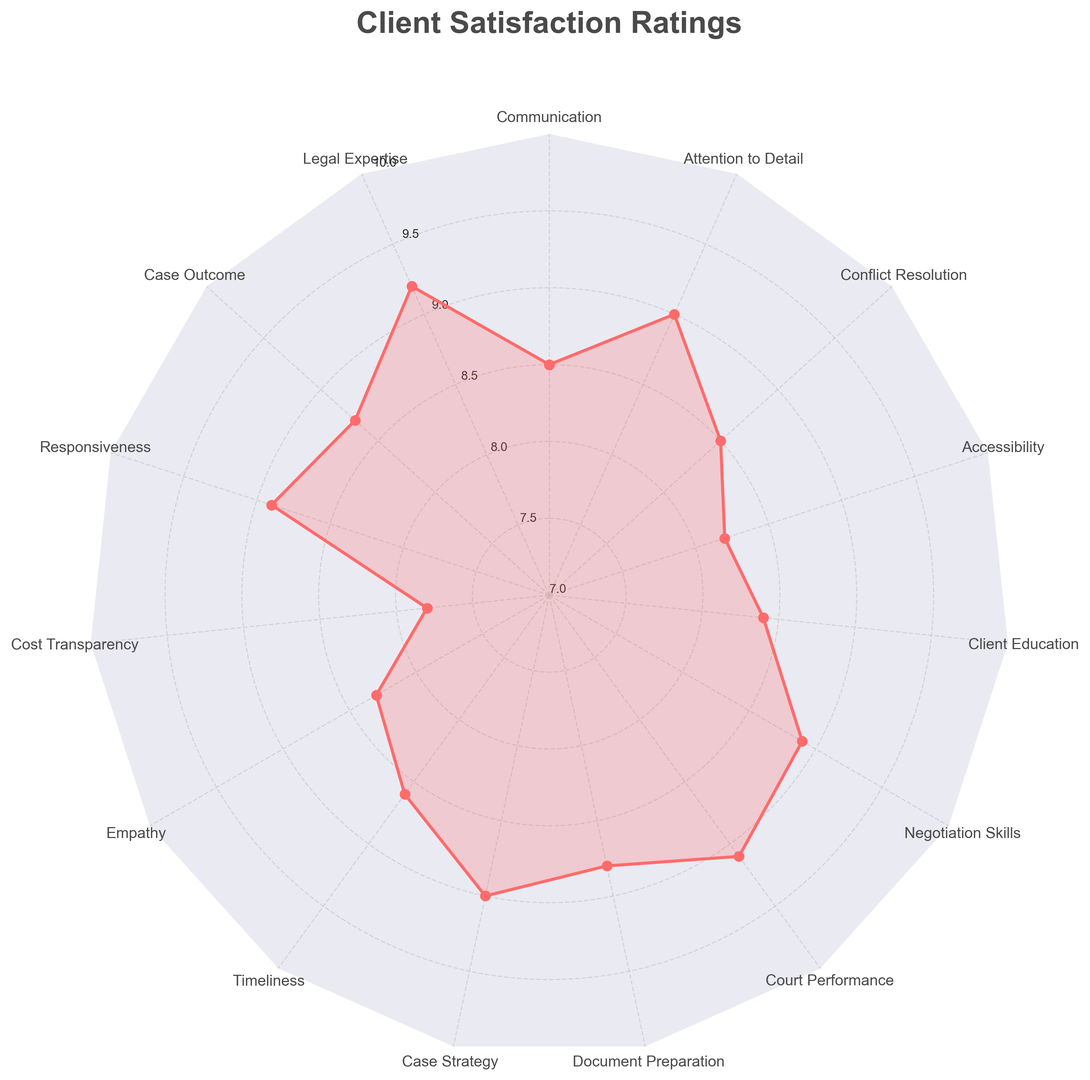what is the highest satisfaction rating? The highest rating is found by looking at the peak of the radar chart. It corresponds to 'Legal Expertise' with a rating of 9.2.
Answer: 9.2 which aspect has the lowest satisfaction rating? The lowest rating can be identified by checking the smallest value on the radar chart. It corresponds to 'Cost Transparency' with a rating of 7.8.
Answer: Cost Transparency compare the ratings for 'Responsiveness' and 'Empathy'. Which is higher? Look at the values for both aspects on the radar chart. 'Responsiveness' has a rating of 8.9, while 'Empathy' has a rating of 8.3. 8.9 is higher than 8.3.
Answer: Responsiveness what is the average rating across all aspects? Summing all ratings and dividing by the number of aspects yields the average. Sum = 132.9, Number of aspects = 15. Average = 132.9 / 15 = 8.86.
Answer: 8.86 are there any aspects with equal ratings? Check the radar chart for ratings that are the same. 'Communication' and 'Conflict Resolution' both have a rating of 8.5.
Answer: Communication, Conflict Resolution how does 'Case Outcome' compare with the average rating? 'Case Outcome' has a rating of 8.7. Compare it with the average rating of 8.86. 8.7 is slightly below 8.86.
Answer: below average what is the median rating of all aspects? List all ratings and find the median. Ratings ordered: 7.8, 8.2, 8.3, 8.4, 8.5, 8.5, 8.6, 8.7, 8.8, 8.9, 8.9, 9.0, 9.0, 9.1, 9.2. Median is the middle value: 8.7.
Answer: 8.7 which aspects have ratings greater than 9.0? Identify aspects with values greater than 9.0 on the radar chart. They are 'Legal Expertise' (9.2) and 'Court Performance' (9.1).
Answer: Legal Expertise, Court Performance how many aspects have ratings between 8.5 and 9.0 inclusive? Count the number of aspects with ratings in this range. They are 'Communication', 'Case Outcome', 'Responsiveness', 'Empathy', 'Timeliness', 'Document Preparation', 'Negotiation Skills', 'Attention to Detail': total 8 aspects.
Answer: 8 